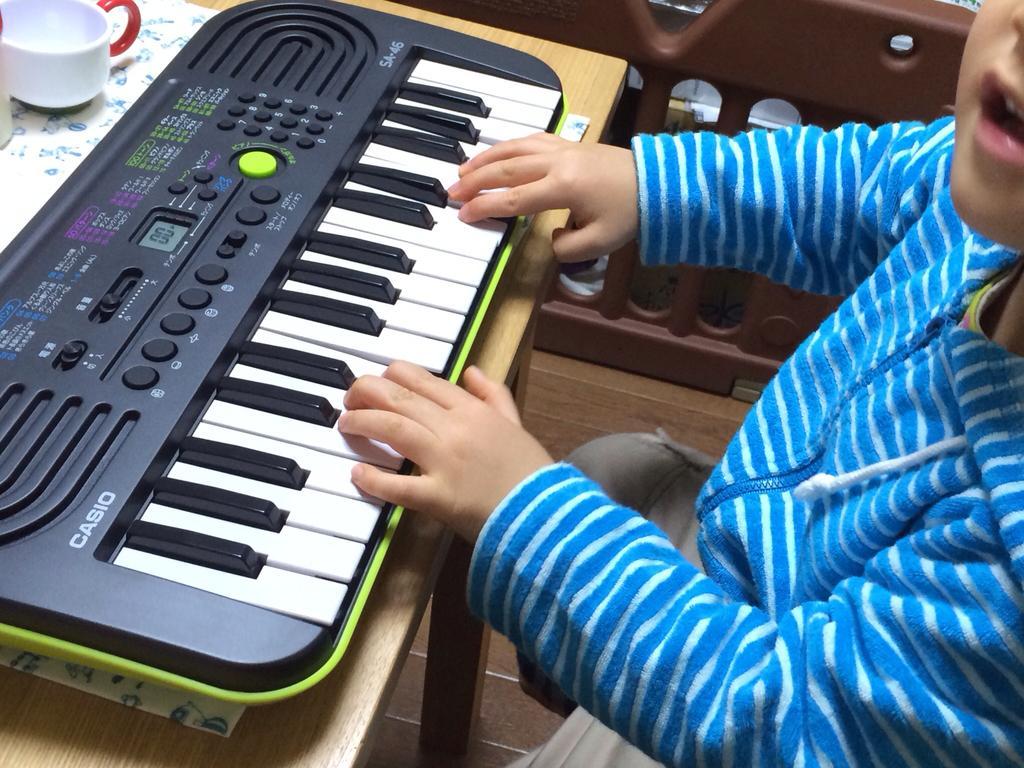Could you give a brief overview of what you see in this image? There is a kid sitting in a chair in front of a piano placed on the table. There is a cup and a paper on the table. 